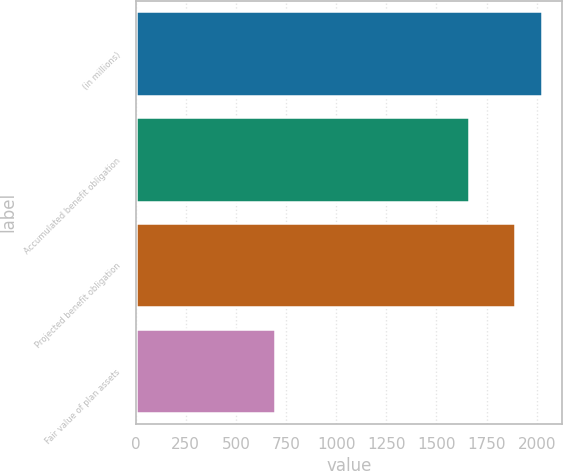Convert chart to OTSL. <chart><loc_0><loc_0><loc_500><loc_500><bar_chart><fcel>(in millions)<fcel>Accumulated benefit obligation<fcel>Projected benefit obligation<fcel>Fair value of plan assets<nl><fcel>2024.1<fcel>1664<fcel>1892<fcel>696<nl></chart> 